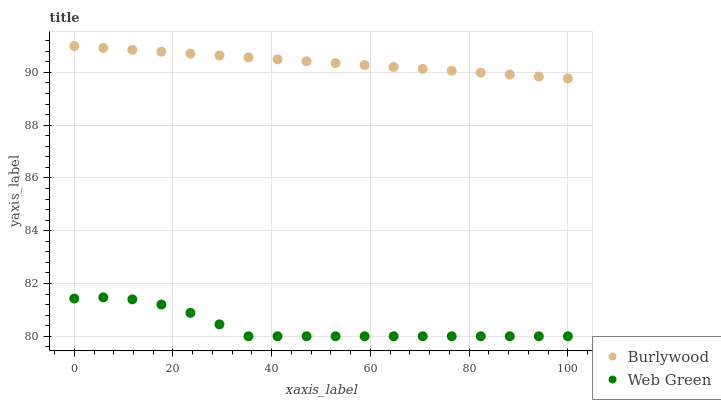Does Web Green have the minimum area under the curve?
Answer yes or no. Yes. Does Burlywood have the maximum area under the curve?
Answer yes or no. Yes. Does Web Green have the maximum area under the curve?
Answer yes or no. No. Is Burlywood the smoothest?
Answer yes or no. Yes. Is Web Green the roughest?
Answer yes or no. Yes. Is Web Green the smoothest?
Answer yes or no. No. Does Web Green have the lowest value?
Answer yes or no. Yes. Does Burlywood have the highest value?
Answer yes or no. Yes. Does Web Green have the highest value?
Answer yes or no. No. Is Web Green less than Burlywood?
Answer yes or no. Yes. Is Burlywood greater than Web Green?
Answer yes or no. Yes. Does Web Green intersect Burlywood?
Answer yes or no. No. 